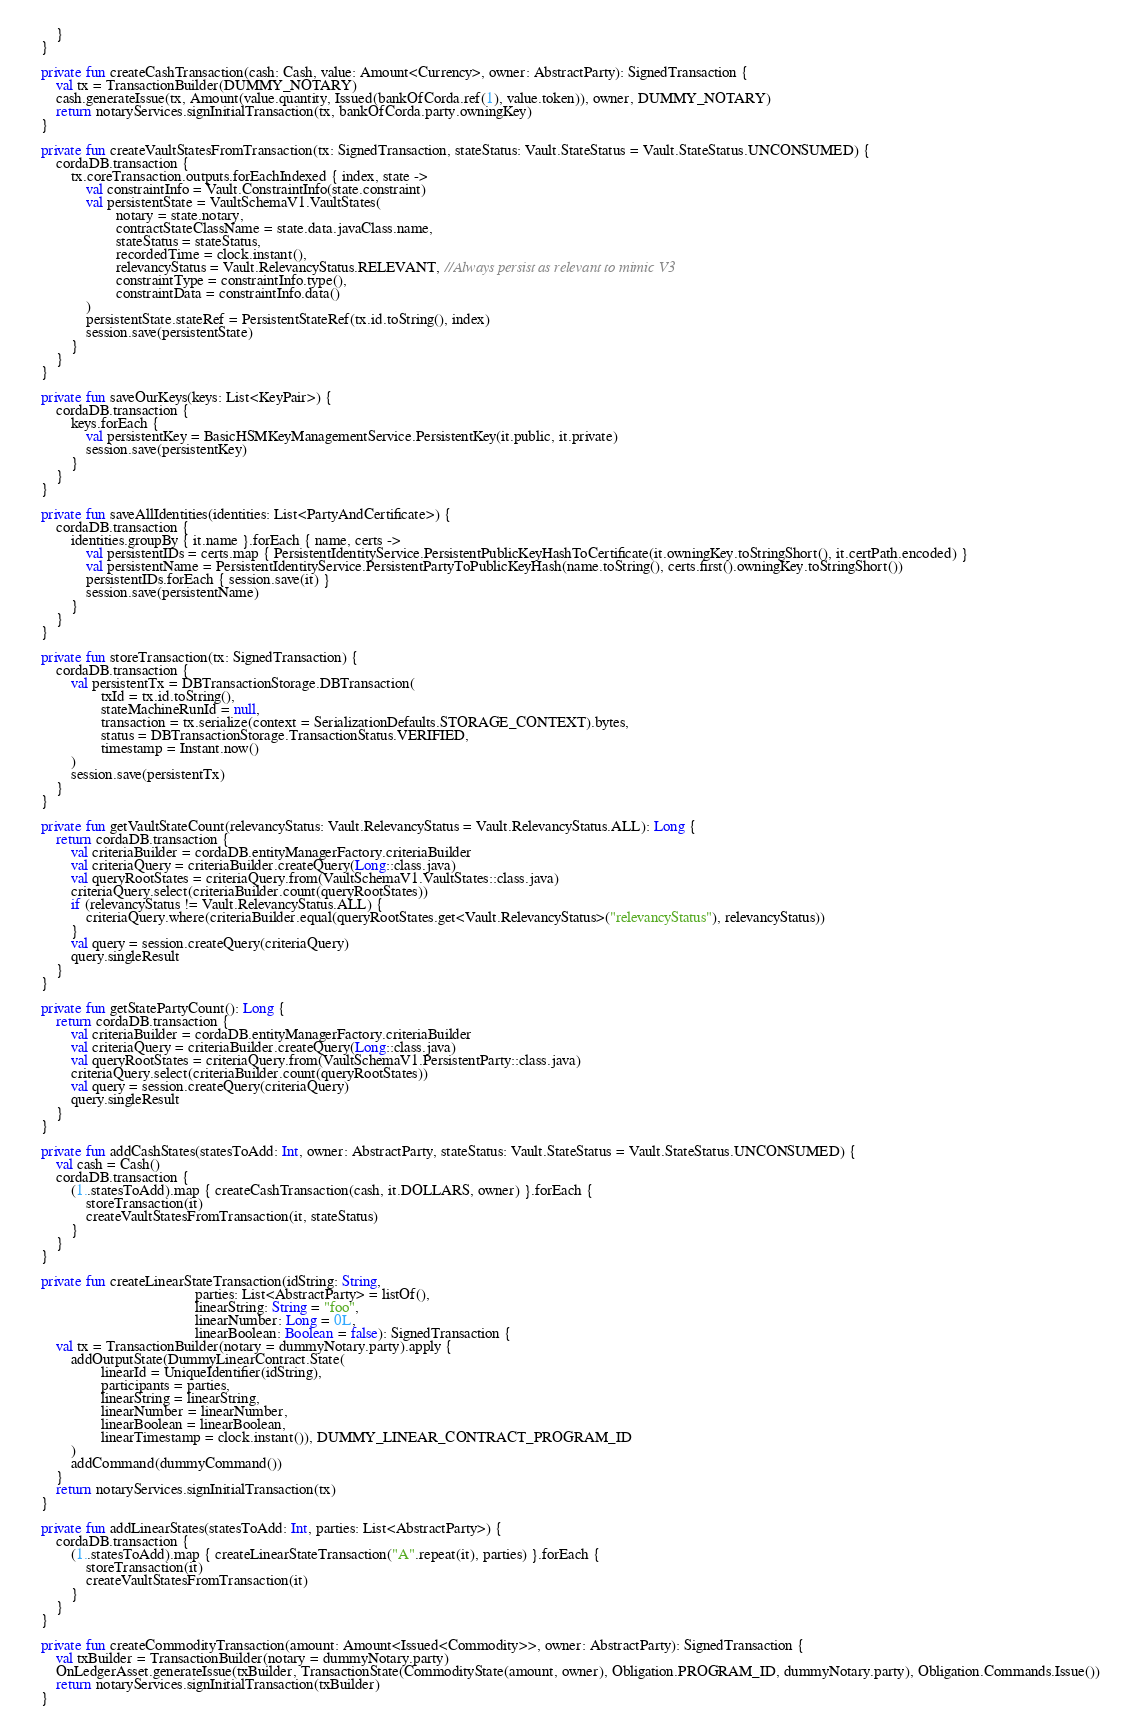Convert code to text. <code><loc_0><loc_0><loc_500><loc_500><_Kotlin_>        }
    }

    private fun createCashTransaction(cash: Cash, value: Amount<Currency>, owner: AbstractParty): SignedTransaction {
        val tx = TransactionBuilder(DUMMY_NOTARY)
        cash.generateIssue(tx, Amount(value.quantity, Issued(bankOfCorda.ref(1), value.token)), owner, DUMMY_NOTARY)
        return notaryServices.signInitialTransaction(tx, bankOfCorda.party.owningKey)
    }

    private fun createVaultStatesFromTransaction(tx: SignedTransaction, stateStatus: Vault.StateStatus = Vault.StateStatus.UNCONSUMED) {
        cordaDB.transaction {
            tx.coreTransaction.outputs.forEachIndexed { index, state ->
                val constraintInfo = Vault.ConstraintInfo(state.constraint)
                val persistentState = VaultSchemaV1.VaultStates(
                        notary = state.notary,
                        contractStateClassName = state.data.javaClass.name,
                        stateStatus = stateStatus,
                        recordedTime = clock.instant(),
                        relevancyStatus = Vault.RelevancyStatus.RELEVANT, //Always persist as relevant to mimic V3
                        constraintType = constraintInfo.type(),
                        constraintData = constraintInfo.data()
                )
                persistentState.stateRef = PersistentStateRef(tx.id.toString(), index)
                session.save(persistentState)
            }
        }
    }

    private fun saveOurKeys(keys: List<KeyPair>) {
        cordaDB.transaction {
            keys.forEach {
                val persistentKey = BasicHSMKeyManagementService.PersistentKey(it.public, it.private)
                session.save(persistentKey)
            }
        }
    }

    private fun saveAllIdentities(identities: List<PartyAndCertificate>) {
        cordaDB.transaction {
            identities.groupBy { it.name }.forEach { name, certs ->
                val persistentIDs = certs.map { PersistentIdentityService.PersistentPublicKeyHashToCertificate(it.owningKey.toStringShort(), it.certPath.encoded) }
                val persistentName = PersistentIdentityService.PersistentPartyToPublicKeyHash(name.toString(), certs.first().owningKey.toStringShort())
                persistentIDs.forEach { session.save(it) }
                session.save(persistentName)
            }
        }
    }

    private fun storeTransaction(tx: SignedTransaction) {
        cordaDB.transaction {
            val persistentTx = DBTransactionStorage.DBTransaction(
                    txId = tx.id.toString(),
                    stateMachineRunId = null,
                    transaction = tx.serialize(context = SerializationDefaults.STORAGE_CONTEXT).bytes,
                    status = DBTransactionStorage.TransactionStatus.VERIFIED,
                    timestamp = Instant.now()
            )
            session.save(persistentTx)
        }
    }

    private fun getVaultStateCount(relevancyStatus: Vault.RelevancyStatus = Vault.RelevancyStatus.ALL): Long {
        return cordaDB.transaction {
            val criteriaBuilder = cordaDB.entityManagerFactory.criteriaBuilder
            val criteriaQuery = criteriaBuilder.createQuery(Long::class.java)
            val queryRootStates = criteriaQuery.from(VaultSchemaV1.VaultStates::class.java)
            criteriaQuery.select(criteriaBuilder.count(queryRootStates))
            if (relevancyStatus != Vault.RelevancyStatus.ALL) {
                criteriaQuery.where(criteriaBuilder.equal(queryRootStates.get<Vault.RelevancyStatus>("relevancyStatus"), relevancyStatus))
            }
            val query = session.createQuery(criteriaQuery)
            query.singleResult
        }
    }

    private fun getStatePartyCount(): Long {
        return cordaDB.transaction {
            val criteriaBuilder = cordaDB.entityManagerFactory.criteriaBuilder
            val criteriaQuery = criteriaBuilder.createQuery(Long::class.java)
            val queryRootStates = criteriaQuery.from(VaultSchemaV1.PersistentParty::class.java)
            criteriaQuery.select(criteriaBuilder.count(queryRootStates))
            val query = session.createQuery(criteriaQuery)
            query.singleResult
        }
    }

    private fun addCashStates(statesToAdd: Int, owner: AbstractParty, stateStatus: Vault.StateStatus = Vault.StateStatus.UNCONSUMED) {
        val cash = Cash()
        cordaDB.transaction {
            (1..statesToAdd).map { createCashTransaction(cash, it.DOLLARS, owner) }.forEach {
                storeTransaction(it)
                createVaultStatesFromTransaction(it, stateStatus)
            }
        }
    }

    private fun createLinearStateTransaction(idString: String,
                                             parties: List<AbstractParty> = listOf(),
                                             linearString: String = "foo",
                                             linearNumber: Long = 0L,
                                             linearBoolean: Boolean = false): SignedTransaction {
        val tx = TransactionBuilder(notary = dummyNotary.party).apply {
            addOutputState(DummyLinearContract.State(
                    linearId = UniqueIdentifier(idString),
                    participants = parties,
                    linearString = linearString,
                    linearNumber = linearNumber,
                    linearBoolean = linearBoolean,
                    linearTimestamp = clock.instant()), DUMMY_LINEAR_CONTRACT_PROGRAM_ID
            )
            addCommand(dummyCommand())
        }
        return notaryServices.signInitialTransaction(tx)
    }

    private fun addLinearStates(statesToAdd: Int, parties: List<AbstractParty>) {
        cordaDB.transaction {
            (1..statesToAdd).map { createLinearStateTransaction("A".repeat(it), parties) }.forEach {
                storeTransaction(it)
                createVaultStatesFromTransaction(it)
            }
        }
    }

    private fun createCommodityTransaction(amount: Amount<Issued<Commodity>>, owner: AbstractParty): SignedTransaction {
        val txBuilder = TransactionBuilder(notary = dummyNotary.party)
        OnLedgerAsset.generateIssue(txBuilder, TransactionState(CommodityState(amount, owner), Obligation.PROGRAM_ID, dummyNotary.party), Obligation.Commands.Issue())
        return notaryServices.signInitialTransaction(txBuilder)
    }
</code> 